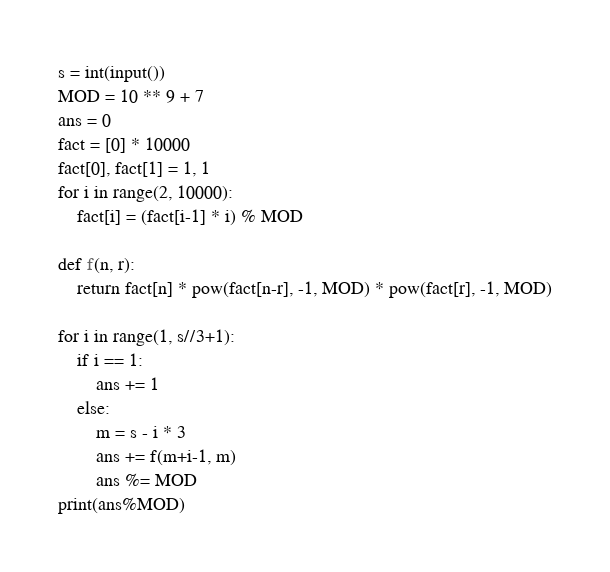Convert code to text. <code><loc_0><loc_0><loc_500><loc_500><_Python_>s = int(input())
MOD = 10 ** 9 + 7
ans = 0
fact = [0] * 10000
fact[0], fact[1] = 1, 1
for i in range(2, 10000):
    fact[i] = (fact[i-1] * i) % MOD

def f(n, r):
    return fact[n] * pow(fact[n-r], -1, MOD) * pow(fact[r], -1, MOD)

for i in range(1, s//3+1):
    if i == 1:
        ans += 1
    else:
        m = s - i * 3
        ans += f(m+i-1, m)
        ans %= MOD
print(ans%MOD)</code> 